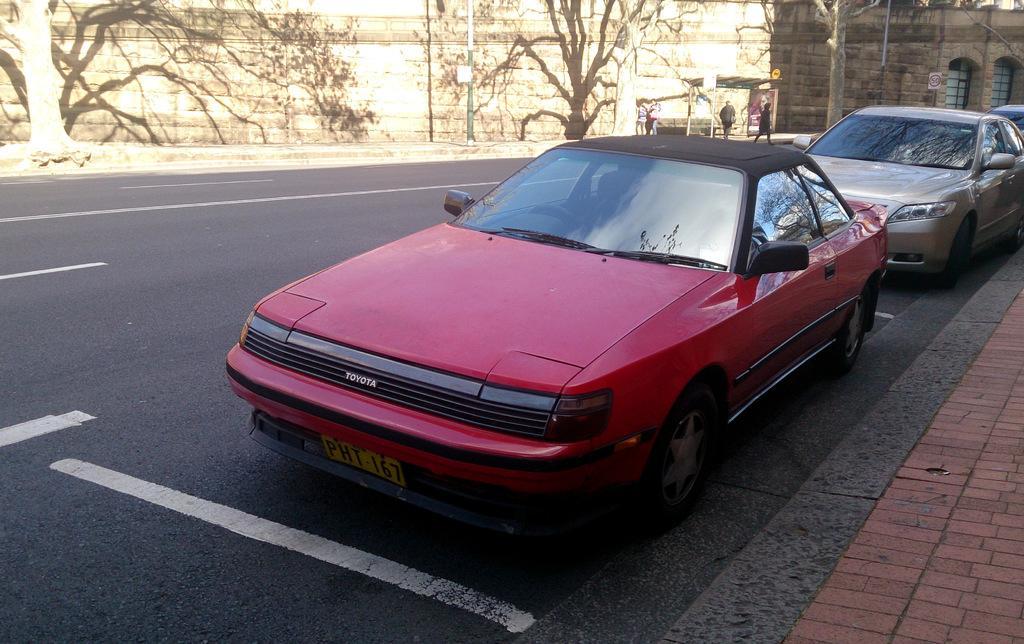Could you give a brief overview of what you see in this image? We can see cars on the road. Background we can see wall,trees and people. 